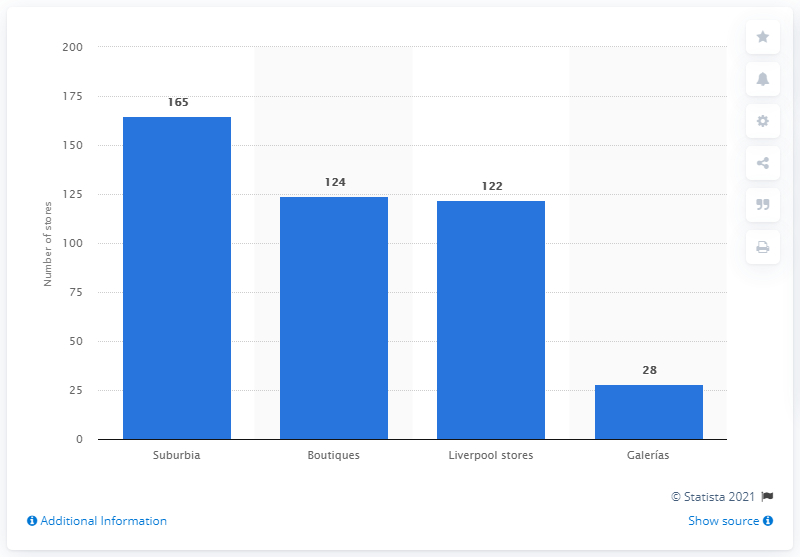Mention a couple of crucial points in this snapshot. As of 2020, El Puerto de Liverpool had a total of 28 shopping malls. 